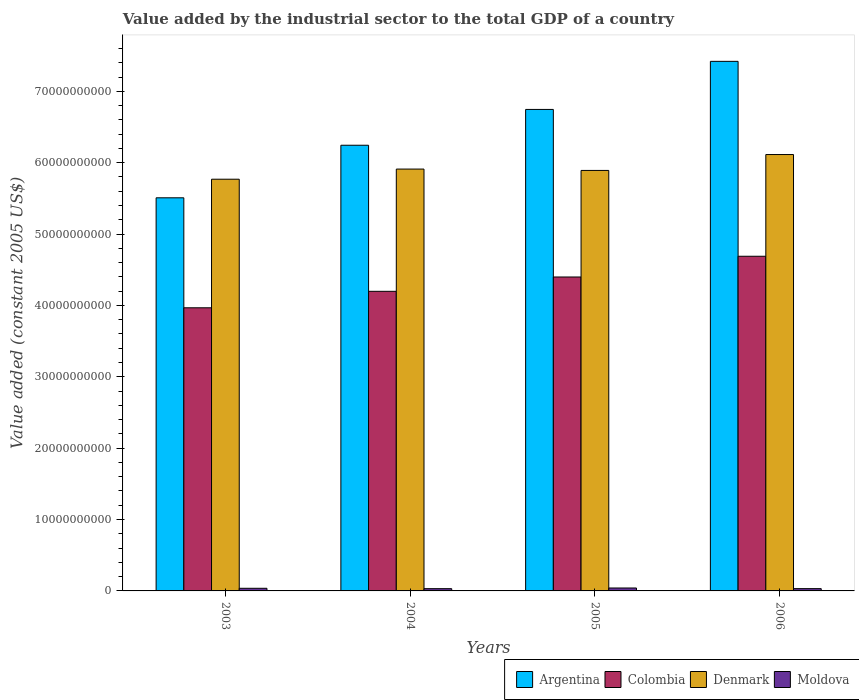How many different coloured bars are there?
Your answer should be very brief. 4. How many groups of bars are there?
Ensure brevity in your answer.  4. Are the number of bars per tick equal to the number of legend labels?
Ensure brevity in your answer.  Yes. In how many cases, is the number of bars for a given year not equal to the number of legend labels?
Make the answer very short. 0. What is the value added by the industrial sector in Colombia in 2004?
Ensure brevity in your answer.  4.20e+1. Across all years, what is the maximum value added by the industrial sector in Argentina?
Your answer should be very brief. 7.42e+1. Across all years, what is the minimum value added by the industrial sector in Colombia?
Provide a succinct answer. 3.97e+1. In which year was the value added by the industrial sector in Colombia minimum?
Offer a terse response. 2003. What is the total value added by the industrial sector in Moldova in the graph?
Offer a very short reply. 1.41e+09. What is the difference between the value added by the industrial sector in Colombia in 2004 and that in 2006?
Provide a succinct answer. -4.91e+09. What is the difference between the value added by the industrial sector in Denmark in 2005 and the value added by the industrial sector in Argentina in 2004?
Make the answer very short. -3.53e+09. What is the average value added by the industrial sector in Colombia per year?
Keep it short and to the point. 4.31e+1. In the year 2003, what is the difference between the value added by the industrial sector in Denmark and value added by the industrial sector in Moldova?
Offer a very short reply. 5.73e+1. In how many years, is the value added by the industrial sector in Moldova greater than 24000000000 US$?
Provide a succinct answer. 0. What is the ratio of the value added by the industrial sector in Denmark in 2004 to that in 2006?
Offer a very short reply. 0.97. Is the value added by the industrial sector in Argentina in 2005 less than that in 2006?
Provide a short and direct response. Yes. Is the difference between the value added by the industrial sector in Denmark in 2004 and 2005 greater than the difference between the value added by the industrial sector in Moldova in 2004 and 2005?
Give a very brief answer. Yes. What is the difference between the highest and the second highest value added by the industrial sector in Moldova?
Ensure brevity in your answer.  4.14e+07. What is the difference between the highest and the lowest value added by the industrial sector in Moldova?
Ensure brevity in your answer.  9.43e+07. Is the sum of the value added by the industrial sector in Colombia in 2005 and 2006 greater than the maximum value added by the industrial sector in Argentina across all years?
Provide a succinct answer. Yes. What does the 4th bar from the left in 2004 represents?
Ensure brevity in your answer.  Moldova. What does the 1st bar from the right in 2006 represents?
Keep it short and to the point. Moldova. Is it the case that in every year, the sum of the value added by the industrial sector in Denmark and value added by the industrial sector in Moldova is greater than the value added by the industrial sector in Colombia?
Your response must be concise. Yes. Are the values on the major ticks of Y-axis written in scientific E-notation?
Ensure brevity in your answer.  No. How are the legend labels stacked?
Your answer should be very brief. Horizontal. What is the title of the graph?
Your answer should be very brief. Value added by the industrial sector to the total GDP of a country. Does "New Zealand" appear as one of the legend labels in the graph?
Your answer should be very brief. No. What is the label or title of the Y-axis?
Your answer should be compact. Value added (constant 2005 US$). What is the Value added (constant 2005 US$) in Argentina in 2003?
Your answer should be compact. 5.51e+1. What is the Value added (constant 2005 US$) of Colombia in 2003?
Offer a terse response. 3.97e+1. What is the Value added (constant 2005 US$) of Denmark in 2003?
Keep it short and to the point. 5.77e+1. What is the Value added (constant 2005 US$) in Moldova in 2003?
Your response must be concise. 3.69e+08. What is the Value added (constant 2005 US$) in Argentina in 2004?
Provide a short and direct response. 6.24e+1. What is the Value added (constant 2005 US$) in Colombia in 2004?
Your answer should be very brief. 4.20e+1. What is the Value added (constant 2005 US$) in Denmark in 2004?
Give a very brief answer. 5.91e+1. What is the Value added (constant 2005 US$) of Moldova in 2004?
Make the answer very short. 3.16e+08. What is the Value added (constant 2005 US$) in Argentina in 2005?
Offer a very short reply. 6.75e+1. What is the Value added (constant 2005 US$) of Colombia in 2005?
Provide a succinct answer. 4.40e+1. What is the Value added (constant 2005 US$) in Denmark in 2005?
Make the answer very short. 5.89e+1. What is the Value added (constant 2005 US$) in Moldova in 2005?
Provide a succinct answer. 4.10e+08. What is the Value added (constant 2005 US$) of Argentina in 2006?
Provide a short and direct response. 7.42e+1. What is the Value added (constant 2005 US$) of Colombia in 2006?
Ensure brevity in your answer.  4.69e+1. What is the Value added (constant 2005 US$) of Denmark in 2006?
Give a very brief answer. 6.11e+1. What is the Value added (constant 2005 US$) of Moldova in 2006?
Give a very brief answer. 3.20e+08. Across all years, what is the maximum Value added (constant 2005 US$) in Argentina?
Make the answer very short. 7.42e+1. Across all years, what is the maximum Value added (constant 2005 US$) of Colombia?
Offer a terse response. 4.69e+1. Across all years, what is the maximum Value added (constant 2005 US$) in Denmark?
Offer a terse response. 6.11e+1. Across all years, what is the maximum Value added (constant 2005 US$) of Moldova?
Your answer should be very brief. 4.10e+08. Across all years, what is the minimum Value added (constant 2005 US$) in Argentina?
Your answer should be very brief. 5.51e+1. Across all years, what is the minimum Value added (constant 2005 US$) of Colombia?
Your response must be concise. 3.97e+1. Across all years, what is the minimum Value added (constant 2005 US$) in Denmark?
Your answer should be compact. 5.77e+1. Across all years, what is the minimum Value added (constant 2005 US$) of Moldova?
Provide a succinct answer. 3.16e+08. What is the total Value added (constant 2005 US$) of Argentina in the graph?
Give a very brief answer. 2.59e+11. What is the total Value added (constant 2005 US$) in Colombia in the graph?
Offer a very short reply. 1.73e+11. What is the total Value added (constant 2005 US$) of Denmark in the graph?
Make the answer very short. 2.37e+11. What is the total Value added (constant 2005 US$) of Moldova in the graph?
Your answer should be very brief. 1.41e+09. What is the difference between the Value added (constant 2005 US$) of Argentina in 2003 and that in 2004?
Offer a very short reply. -7.36e+09. What is the difference between the Value added (constant 2005 US$) in Colombia in 2003 and that in 2004?
Keep it short and to the point. -2.31e+09. What is the difference between the Value added (constant 2005 US$) of Denmark in 2003 and that in 2004?
Provide a short and direct response. -1.42e+09. What is the difference between the Value added (constant 2005 US$) of Moldova in 2003 and that in 2004?
Offer a terse response. 5.29e+07. What is the difference between the Value added (constant 2005 US$) in Argentina in 2003 and that in 2005?
Provide a succinct answer. -1.24e+1. What is the difference between the Value added (constant 2005 US$) of Colombia in 2003 and that in 2005?
Your response must be concise. -4.32e+09. What is the difference between the Value added (constant 2005 US$) of Denmark in 2003 and that in 2005?
Your answer should be compact. -1.23e+09. What is the difference between the Value added (constant 2005 US$) of Moldova in 2003 and that in 2005?
Keep it short and to the point. -4.14e+07. What is the difference between the Value added (constant 2005 US$) in Argentina in 2003 and that in 2006?
Ensure brevity in your answer.  -1.91e+1. What is the difference between the Value added (constant 2005 US$) in Colombia in 2003 and that in 2006?
Your response must be concise. -7.22e+09. What is the difference between the Value added (constant 2005 US$) in Denmark in 2003 and that in 2006?
Offer a very short reply. -3.46e+09. What is the difference between the Value added (constant 2005 US$) of Moldova in 2003 and that in 2006?
Ensure brevity in your answer.  4.89e+07. What is the difference between the Value added (constant 2005 US$) of Argentina in 2004 and that in 2005?
Provide a succinct answer. -5.02e+09. What is the difference between the Value added (constant 2005 US$) of Colombia in 2004 and that in 2005?
Offer a terse response. -2.01e+09. What is the difference between the Value added (constant 2005 US$) in Denmark in 2004 and that in 2005?
Give a very brief answer. 1.89e+08. What is the difference between the Value added (constant 2005 US$) of Moldova in 2004 and that in 2005?
Your answer should be compact. -9.43e+07. What is the difference between the Value added (constant 2005 US$) in Argentina in 2004 and that in 2006?
Keep it short and to the point. -1.18e+1. What is the difference between the Value added (constant 2005 US$) in Colombia in 2004 and that in 2006?
Provide a succinct answer. -4.91e+09. What is the difference between the Value added (constant 2005 US$) in Denmark in 2004 and that in 2006?
Provide a short and direct response. -2.04e+09. What is the difference between the Value added (constant 2005 US$) of Moldova in 2004 and that in 2006?
Keep it short and to the point. -4.00e+06. What is the difference between the Value added (constant 2005 US$) in Argentina in 2005 and that in 2006?
Offer a very short reply. -6.74e+09. What is the difference between the Value added (constant 2005 US$) in Colombia in 2005 and that in 2006?
Your response must be concise. -2.90e+09. What is the difference between the Value added (constant 2005 US$) of Denmark in 2005 and that in 2006?
Provide a succinct answer. -2.22e+09. What is the difference between the Value added (constant 2005 US$) of Moldova in 2005 and that in 2006?
Keep it short and to the point. 9.03e+07. What is the difference between the Value added (constant 2005 US$) of Argentina in 2003 and the Value added (constant 2005 US$) of Colombia in 2004?
Make the answer very short. 1.31e+1. What is the difference between the Value added (constant 2005 US$) of Argentina in 2003 and the Value added (constant 2005 US$) of Denmark in 2004?
Ensure brevity in your answer.  -4.02e+09. What is the difference between the Value added (constant 2005 US$) of Argentina in 2003 and the Value added (constant 2005 US$) of Moldova in 2004?
Ensure brevity in your answer.  5.48e+1. What is the difference between the Value added (constant 2005 US$) in Colombia in 2003 and the Value added (constant 2005 US$) in Denmark in 2004?
Provide a short and direct response. -1.94e+1. What is the difference between the Value added (constant 2005 US$) in Colombia in 2003 and the Value added (constant 2005 US$) in Moldova in 2004?
Make the answer very short. 3.94e+1. What is the difference between the Value added (constant 2005 US$) in Denmark in 2003 and the Value added (constant 2005 US$) in Moldova in 2004?
Keep it short and to the point. 5.74e+1. What is the difference between the Value added (constant 2005 US$) of Argentina in 2003 and the Value added (constant 2005 US$) of Colombia in 2005?
Your answer should be very brief. 1.11e+1. What is the difference between the Value added (constant 2005 US$) in Argentina in 2003 and the Value added (constant 2005 US$) in Denmark in 2005?
Provide a succinct answer. -3.84e+09. What is the difference between the Value added (constant 2005 US$) of Argentina in 2003 and the Value added (constant 2005 US$) of Moldova in 2005?
Your answer should be compact. 5.47e+1. What is the difference between the Value added (constant 2005 US$) of Colombia in 2003 and the Value added (constant 2005 US$) of Denmark in 2005?
Offer a terse response. -1.92e+1. What is the difference between the Value added (constant 2005 US$) of Colombia in 2003 and the Value added (constant 2005 US$) of Moldova in 2005?
Your response must be concise. 3.93e+1. What is the difference between the Value added (constant 2005 US$) in Denmark in 2003 and the Value added (constant 2005 US$) in Moldova in 2005?
Your response must be concise. 5.73e+1. What is the difference between the Value added (constant 2005 US$) of Argentina in 2003 and the Value added (constant 2005 US$) of Colombia in 2006?
Your response must be concise. 8.19e+09. What is the difference between the Value added (constant 2005 US$) of Argentina in 2003 and the Value added (constant 2005 US$) of Denmark in 2006?
Keep it short and to the point. -6.06e+09. What is the difference between the Value added (constant 2005 US$) of Argentina in 2003 and the Value added (constant 2005 US$) of Moldova in 2006?
Your answer should be compact. 5.48e+1. What is the difference between the Value added (constant 2005 US$) in Colombia in 2003 and the Value added (constant 2005 US$) in Denmark in 2006?
Provide a succinct answer. -2.15e+1. What is the difference between the Value added (constant 2005 US$) in Colombia in 2003 and the Value added (constant 2005 US$) in Moldova in 2006?
Offer a terse response. 3.93e+1. What is the difference between the Value added (constant 2005 US$) in Denmark in 2003 and the Value added (constant 2005 US$) in Moldova in 2006?
Give a very brief answer. 5.74e+1. What is the difference between the Value added (constant 2005 US$) of Argentina in 2004 and the Value added (constant 2005 US$) of Colombia in 2005?
Offer a very short reply. 1.85e+1. What is the difference between the Value added (constant 2005 US$) of Argentina in 2004 and the Value added (constant 2005 US$) of Denmark in 2005?
Offer a terse response. 3.53e+09. What is the difference between the Value added (constant 2005 US$) of Argentina in 2004 and the Value added (constant 2005 US$) of Moldova in 2005?
Give a very brief answer. 6.20e+1. What is the difference between the Value added (constant 2005 US$) in Colombia in 2004 and the Value added (constant 2005 US$) in Denmark in 2005?
Provide a short and direct response. -1.69e+1. What is the difference between the Value added (constant 2005 US$) in Colombia in 2004 and the Value added (constant 2005 US$) in Moldova in 2005?
Offer a terse response. 4.16e+1. What is the difference between the Value added (constant 2005 US$) of Denmark in 2004 and the Value added (constant 2005 US$) of Moldova in 2005?
Provide a short and direct response. 5.87e+1. What is the difference between the Value added (constant 2005 US$) of Argentina in 2004 and the Value added (constant 2005 US$) of Colombia in 2006?
Offer a terse response. 1.56e+1. What is the difference between the Value added (constant 2005 US$) in Argentina in 2004 and the Value added (constant 2005 US$) in Denmark in 2006?
Your answer should be very brief. 1.30e+09. What is the difference between the Value added (constant 2005 US$) of Argentina in 2004 and the Value added (constant 2005 US$) of Moldova in 2006?
Offer a terse response. 6.21e+1. What is the difference between the Value added (constant 2005 US$) in Colombia in 2004 and the Value added (constant 2005 US$) in Denmark in 2006?
Give a very brief answer. -1.92e+1. What is the difference between the Value added (constant 2005 US$) in Colombia in 2004 and the Value added (constant 2005 US$) in Moldova in 2006?
Keep it short and to the point. 4.17e+1. What is the difference between the Value added (constant 2005 US$) in Denmark in 2004 and the Value added (constant 2005 US$) in Moldova in 2006?
Provide a short and direct response. 5.88e+1. What is the difference between the Value added (constant 2005 US$) of Argentina in 2005 and the Value added (constant 2005 US$) of Colombia in 2006?
Your answer should be very brief. 2.06e+1. What is the difference between the Value added (constant 2005 US$) in Argentina in 2005 and the Value added (constant 2005 US$) in Denmark in 2006?
Your answer should be very brief. 6.32e+09. What is the difference between the Value added (constant 2005 US$) of Argentina in 2005 and the Value added (constant 2005 US$) of Moldova in 2006?
Your response must be concise. 6.71e+1. What is the difference between the Value added (constant 2005 US$) in Colombia in 2005 and the Value added (constant 2005 US$) in Denmark in 2006?
Your response must be concise. -1.72e+1. What is the difference between the Value added (constant 2005 US$) of Colombia in 2005 and the Value added (constant 2005 US$) of Moldova in 2006?
Give a very brief answer. 4.37e+1. What is the difference between the Value added (constant 2005 US$) in Denmark in 2005 and the Value added (constant 2005 US$) in Moldova in 2006?
Provide a short and direct response. 5.86e+1. What is the average Value added (constant 2005 US$) of Argentina per year?
Provide a succinct answer. 6.48e+1. What is the average Value added (constant 2005 US$) of Colombia per year?
Your response must be concise. 4.31e+1. What is the average Value added (constant 2005 US$) of Denmark per year?
Offer a terse response. 5.92e+1. What is the average Value added (constant 2005 US$) of Moldova per year?
Provide a short and direct response. 3.53e+08. In the year 2003, what is the difference between the Value added (constant 2005 US$) in Argentina and Value added (constant 2005 US$) in Colombia?
Your answer should be very brief. 1.54e+1. In the year 2003, what is the difference between the Value added (constant 2005 US$) in Argentina and Value added (constant 2005 US$) in Denmark?
Offer a very short reply. -2.60e+09. In the year 2003, what is the difference between the Value added (constant 2005 US$) of Argentina and Value added (constant 2005 US$) of Moldova?
Ensure brevity in your answer.  5.47e+1. In the year 2003, what is the difference between the Value added (constant 2005 US$) in Colombia and Value added (constant 2005 US$) in Denmark?
Your answer should be compact. -1.80e+1. In the year 2003, what is the difference between the Value added (constant 2005 US$) in Colombia and Value added (constant 2005 US$) in Moldova?
Provide a succinct answer. 3.93e+1. In the year 2003, what is the difference between the Value added (constant 2005 US$) of Denmark and Value added (constant 2005 US$) of Moldova?
Provide a succinct answer. 5.73e+1. In the year 2004, what is the difference between the Value added (constant 2005 US$) of Argentina and Value added (constant 2005 US$) of Colombia?
Ensure brevity in your answer.  2.05e+1. In the year 2004, what is the difference between the Value added (constant 2005 US$) in Argentina and Value added (constant 2005 US$) in Denmark?
Your answer should be compact. 3.34e+09. In the year 2004, what is the difference between the Value added (constant 2005 US$) of Argentina and Value added (constant 2005 US$) of Moldova?
Ensure brevity in your answer.  6.21e+1. In the year 2004, what is the difference between the Value added (constant 2005 US$) in Colombia and Value added (constant 2005 US$) in Denmark?
Give a very brief answer. -1.71e+1. In the year 2004, what is the difference between the Value added (constant 2005 US$) of Colombia and Value added (constant 2005 US$) of Moldova?
Give a very brief answer. 4.17e+1. In the year 2004, what is the difference between the Value added (constant 2005 US$) of Denmark and Value added (constant 2005 US$) of Moldova?
Ensure brevity in your answer.  5.88e+1. In the year 2005, what is the difference between the Value added (constant 2005 US$) in Argentina and Value added (constant 2005 US$) in Colombia?
Offer a terse response. 2.35e+1. In the year 2005, what is the difference between the Value added (constant 2005 US$) of Argentina and Value added (constant 2005 US$) of Denmark?
Your answer should be compact. 8.54e+09. In the year 2005, what is the difference between the Value added (constant 2005 US$) in Argentina and Value added (constant 2005 US$) in Moldova?
Provide a short and direct response. 6.70e+1. In the year 2005, what is the difference between the Value added (constant 2005 US$) in Colombia and Value added (constant 2005 US$) in Denmark?
Your answer should be very brief. -1.49e+1. In the year 2005, what is the difference between the Value added (constant 2005 US$) in Colombia and Value added (constant 2005 US$) in Moldova?
Make the answer very short. 4.36e+1. In the year 2005, what is the difference between the Value added (constant 2005 US$) in Denmark and Value added (constant 2005 US$) in Moldova?
Ensure brevity in your answer.  5.85e+1. In the year 2006, what is the difference between the Value added (constant 2005 US$) of Argentina and Value added (constant 2005 US$) of Colombia?
Offer a very short reply. 2.73e+1. In the year 2006, what is the difference between the Value added (constant 2005 US$) in Argentina and Value added (constant 2005 US$) in Denmark?
Provide a succinct answer. 1.31e+1. In the year 2006, what is the difference between the Value added (constant 2005 US$) of Argentina and Value added (constant 2005 US$) of Moldova?
Provide a short and direct response. 7.39e+1. In the year 2006, what is the difference between the Value added (constant 2005 US$) of Colombia and Value added (constant 2005 US$) of Denmark?
Provide a short and direct response. -1.43e+1. In the year 2006, what is the difference between the Value added (constant 2005 US$) of Colombia and Value added (constant 2005 US$) of Moldova?
Your response must be concise. 4.66e+1. In the year 2006, what is the difference between the Value added (constant 2005 US$) in Denmark and Value added (constant 2005 US$) in Moldova?
Your response must be concise. 6.08e+1. What is the ratio of the Value added (constant 2005 US$) in Argentina in 2003 to that in 2004?
Offer a very short reply. 0.88. What is the ratio of the Value added (constant 2005 US$) in Colombia in 2003 to that in 2004?
Ensure brevity in your answer.  0.94. What is the ratio of the Value added (constant 2005 US$) in Moldova in 2003 to that in 2004?
Offer a very short reply. 1.17. What is the ratio of the Value added (constant 2005 US$) in Argentina in 2003 to that in 2005?
Provide a succinct answer. 0.82. What is the ratio of the Value added (constant 2005 US$) in Colombia in 2003 to that in 2005?
Provide a short and direct response. 0.9. What is the ratio of the Value added (constant 2005 US$) of Denmark in 2003 to that in 2005?
Provide a succinct answer. 0.98. What is the ratio of the Value added (constant 2005 US$) in Moldova in 2003 to that in 2005?
Provide a short and direct response. 0.9. What is the ratio of the Value added (constant 2005 US$) of Argentina in 2003 to that in 2006?
Your answer should be very brief. 0.74. What is the ratio of the Value added (constant 2005 US$) of Colombia in 2003 to that in 2006?
Offer a very short reply. 0.85. What is the ratio of the Value added (constant 2005 US$) in Denmark in 2003 to that in 2006?
Provide a succinct answer. 0.94. What is the ratio of the Value added (constant 2005 US$) in Moldova in 2003 to that in 2006?
Give a very brief answer. 1.15. What is the ratio of the Value added (constant 2005 US$) of Argentina in 2004 to that in 2005?
Offer a terse response. 0.93. What is the ratio of the Value added (constant 2005 US$) in Colombia in 2004 to that in 2005?
Make the answer very short. 0.95. What is the ratio of the Value added (constant 2005 US$) of Moldova in 2004 to that in 2005?
Provide a succinct answer. 0.77. What is the ratio of the Value added (constant 2005 US$) in Argentina in 2004 to that in 2006?
Provide a short and direct response. 0.84. What is the ratio of the Value added (constant 2005 US$) in Colombia in 2004 to that in 2006?
Your answer should be very brief. 0.9. What is the ratio of the Value added (constant 2005 US$) in Denmark in 2004 to that in 2006?
Ensure brevity in your answer.  0.97. What is the ratio of the Value added (constant 2005 US$) in Moldova in 2004 to that in 2006?
Offer a terse response. 0.99. What is the ratio of the Value added (constant 2005 US$) of Argentina in 2005 to that in 2006?
Ensure brevity in your answer.  0.91. What is the ratio of the Value added (constant 2005 US$) of Colombia in 2005 to that in 2006?
Provide a succinct answer. 0.94. What is the ratio of the Value added (constant 2005 US$) in Denmark in 2005 to that in 2006?
Ensure brevity in your answer.  0.96. What is the ratio of the Value added (constant 2005 US$) of Moldova in 2005 to that in 2006?
Provide a short and direct response. 1.28. What is the difference between the highest and the second highest Value added (constant 2005 US$) of Argentina?
Provide a short and direct response. 6.74e+09. What is the difference between the highest and the second highest Value added (constant 2005 US$) of Colombia?
Offer a very short reply. 2.90e+09. What is the difference between the highest and the second highest Value added (constant 2005 US$) in Denmark?
Give a very brief answer. 2.04e+09. What is the difference between the highest and the second highest Value added (constant 2005 US$) of Moldova?
Make the answer very short. 4.14e+07. What is the difference between the highest and the lowest Value added (constant 2005 US$) in Argentina?
Provide a short and direct response. 1.91e+1. What is the difference between the highest and the lowest Value added (constant 2005 US$) of Colombia?
Your response must be concise. 7.22e+09. What is the difference between the highest and the lowest Value added (constant 2005 US$) of Denmark?
Offer a very short reply. 3.46e+09. What is the difference between the highest and the lowest Value added (constant 2005 US$) of Moldova?
Your answer should be compact. 9.43e+07. 